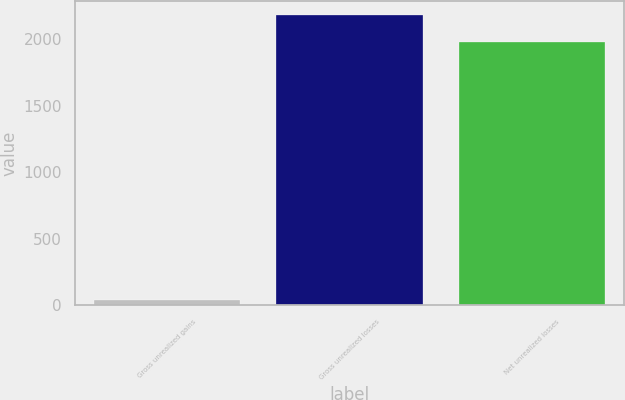Convert chart to OTSL. <chart><loc_0><loc_0><loc_500><loc_500><bar_chart><fcel>Gross unrealized gains<fcel>Gross unrealized losses<fcel>Net unrealized losses<nl><fcel>39<fcel>2181.3<fcel>1983<nl></chart> 